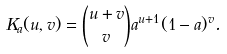Convert formula to latex. <formula><loc_0><loc_0><loc_500><loc_500>K _ { a } ( u , v ) = \binom { u + v } { v } a ^ { u + 1 } ( 1 - a ) ^ { v } .</formula> 